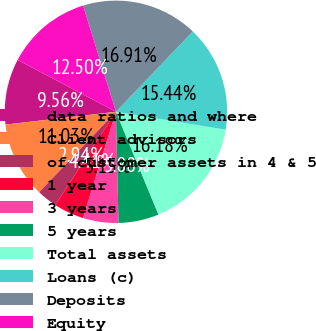Convert chart to OTSL. <chart><loc_0><loc_0><loc_500><loc_500><pie_chart><fcel>data ratios and where<fcel>Client advisors<fcel>of customer assets in 4 & 5<fcel>1 year<fcel>3 years<fcel>5 years<fcel>Total assets<fcel>Loans (c)<fcel>Deposits<fcel>Equity<nl><fcel>9.56%<fcel>11.03%<fcel>2.94%<fcel>4.41%<fcel>5.15%<fcel>5.88%<fcel>16.18%<fcel>15.44%<fcel>16.91%<fcel>12.5%<nl></chart> 